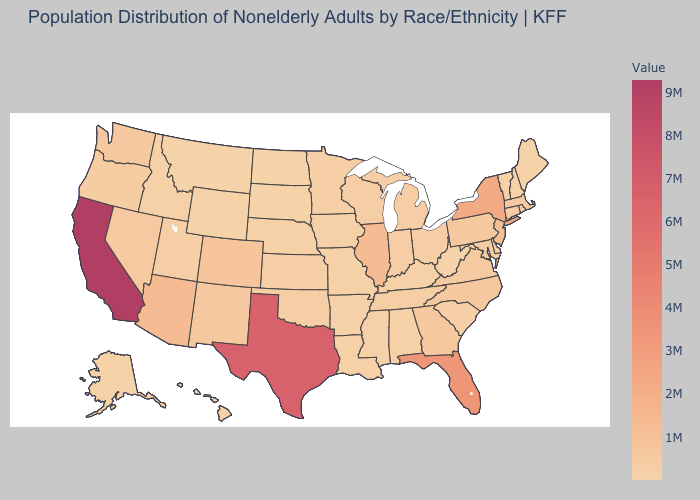Does California have the highest value in the USA?
Be succinct. Yes. Does Illinois have the highest value in the MidWest?
Answer briefly. Yes. Does West Virginia have the lowest value in the USA?
Quick response, please. No. Is the legend a continuous bar?
Give a very brief answer. Yes. Which states have the lowest value in the MidWest?
Be succinct. South Dakota. Does Louisiana have the highest value in the South?
Short answer required. No. 